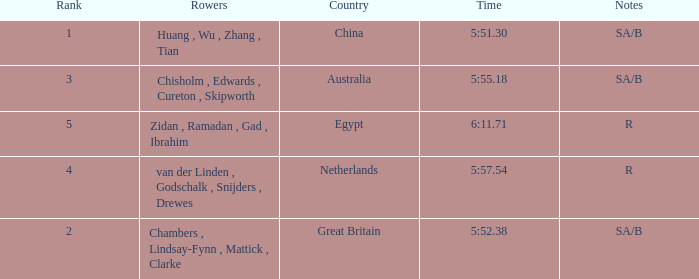What country has sa/b as the notes, and a time of 5:51.30? China. 